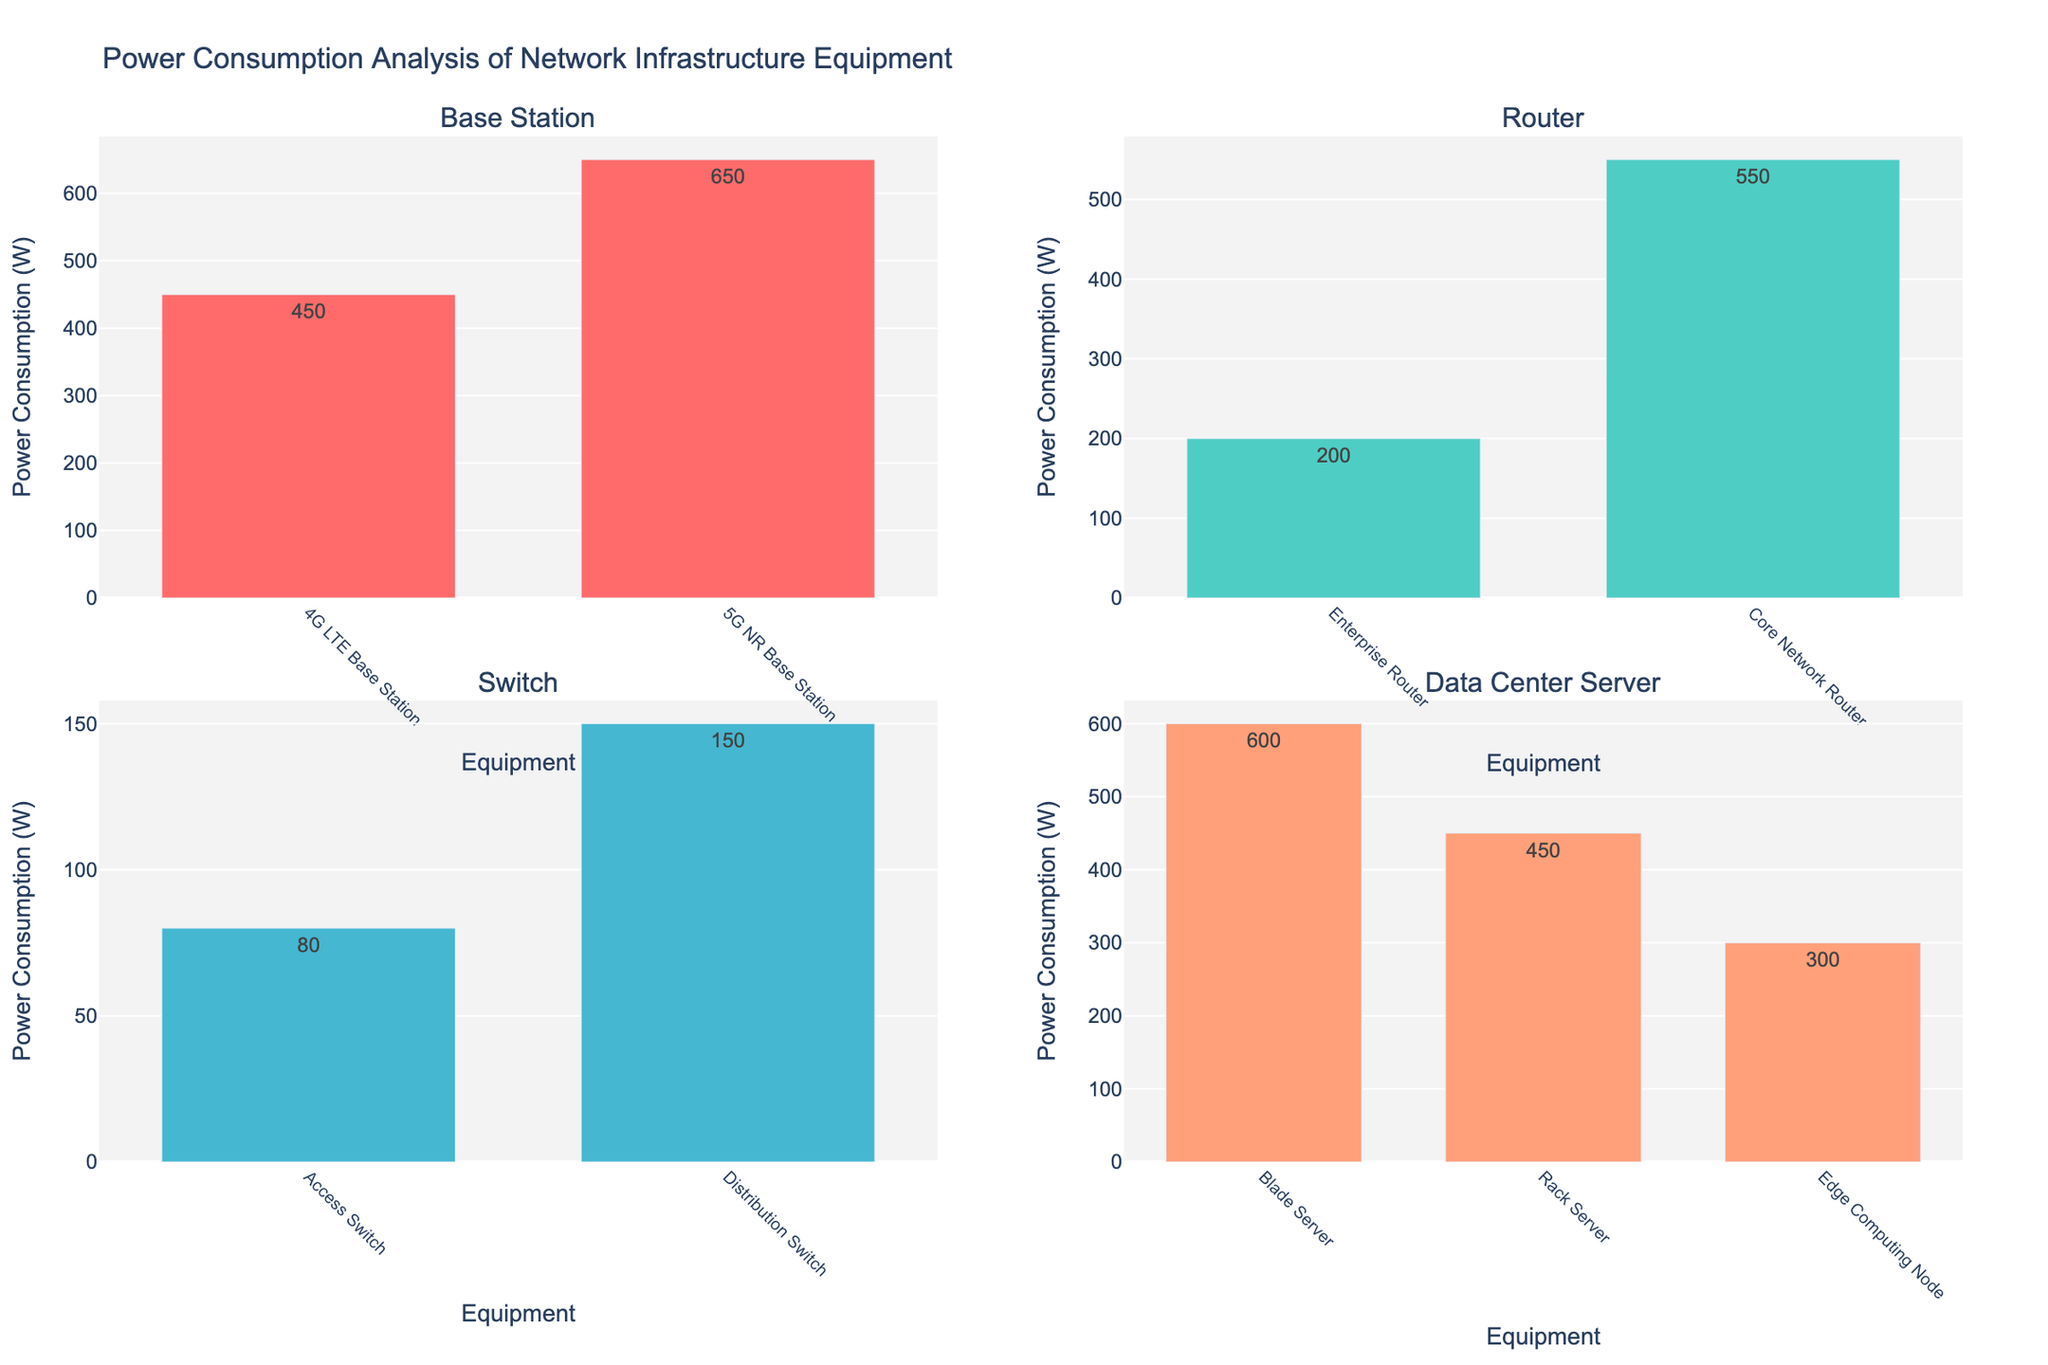What is the overall title of the figure? The overall title is located at the very top of the entire figure. It informs the viewer about the main subject of the visualization.
Answer: Power Consumption Analysis of Network Infrastructure Equipment Which equipment has the highest power consumption in the 4G LTE and 5G NR Base Stations subplot? By looking at the first subplot title "Base Station", we see that the 5G NR Base Station has a higher power consumption value compared to the 4G LTE Base Station.
Answer: 5G NR Base Station How much more power does the 5G NR Base Station consume than the 4G LTE Base Station? Check the power consumption values for both base stations in the first subplot. The 5G NR Base Station consumes 650 W, and the 4G LTE Base Station consumes 450 W. The difference is obtained by subtracting these values: 650 W - 450 W.
Answer: 200 W Which Router has the highest power consumption? In the Router subplot, compare the power consumption of the Enterprise Router and the Core Network Router. The Core Network Router shows 550 W, which is higher than the Enterprise Router's 200 W.
Answer: Core Network Router What is the combined power consumption of the Access Switch and Distribution Switch? Look at the Switch subplot and sum the power consumption values. For Access Switch, it's 80 W, and for Distribution Switch, it's 150 W. The total is 80 W + 150 W.
Answer: 230 W What is the average power consumption of Data Center Servers? Identify the power consumption values in the Data Center Server subplot: Blade Server (600 W), Rack Server (450 W), and Edge Computing Node (300 W). Sum these values and then divide by the number of data points: (600 W + 450 W + 300 W) / 3.
Answer: 450 W Which category contains the highest value within its equipment? Review each subplot's highest bar. Base Station: 650 W (5G NR Base Station), Router: 550 W (Core Network Router), Switch: 150 W (Distribution Switch), Data Center Server: 600 W (Blade Server). The Blade Server in the Data Center Server category has the highest consumption.
Answer: Data Center Server (Blade Server) How does the power consumption of the Core Network Router compare to the Edge Computing Node? Compare the Core Network Router in the Router subplot (550 W) with the Edge Computing Node in the Data Center Server subplot (300 W). The Core Network Router consumes more power.
Answer: Core Network Router consumes more What is the sum of the highest power consumption values for each subplot? Identify the highest values in each subplot: Base Station (650 W), Router (550 W), Switch (150 W), Data Center Server (600 W). Add these values together: 650 W + 550 W + 150 W + 600 W.
Answer: 1950 W 